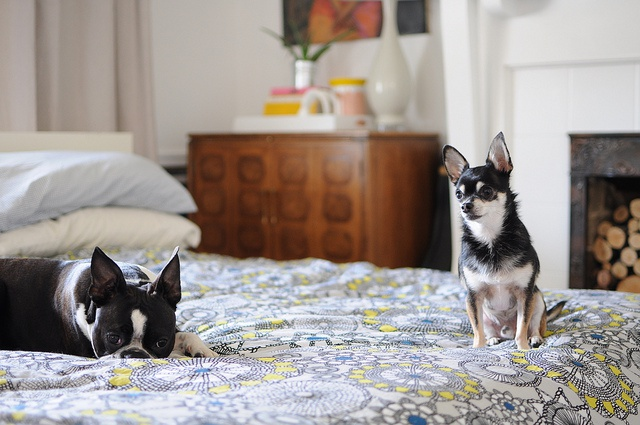Describe the objects in this image and their specific colors. I can see bed in darkgray, lavender, and gray tones, dog in darkgray, black, gray, and lavender tones, dog in darkgray, black, gray, and lightgray tones, dog in darkgray, black, gray, and lightgray tones, and vase in darkgray, lightgray, and gray tones in this image. 